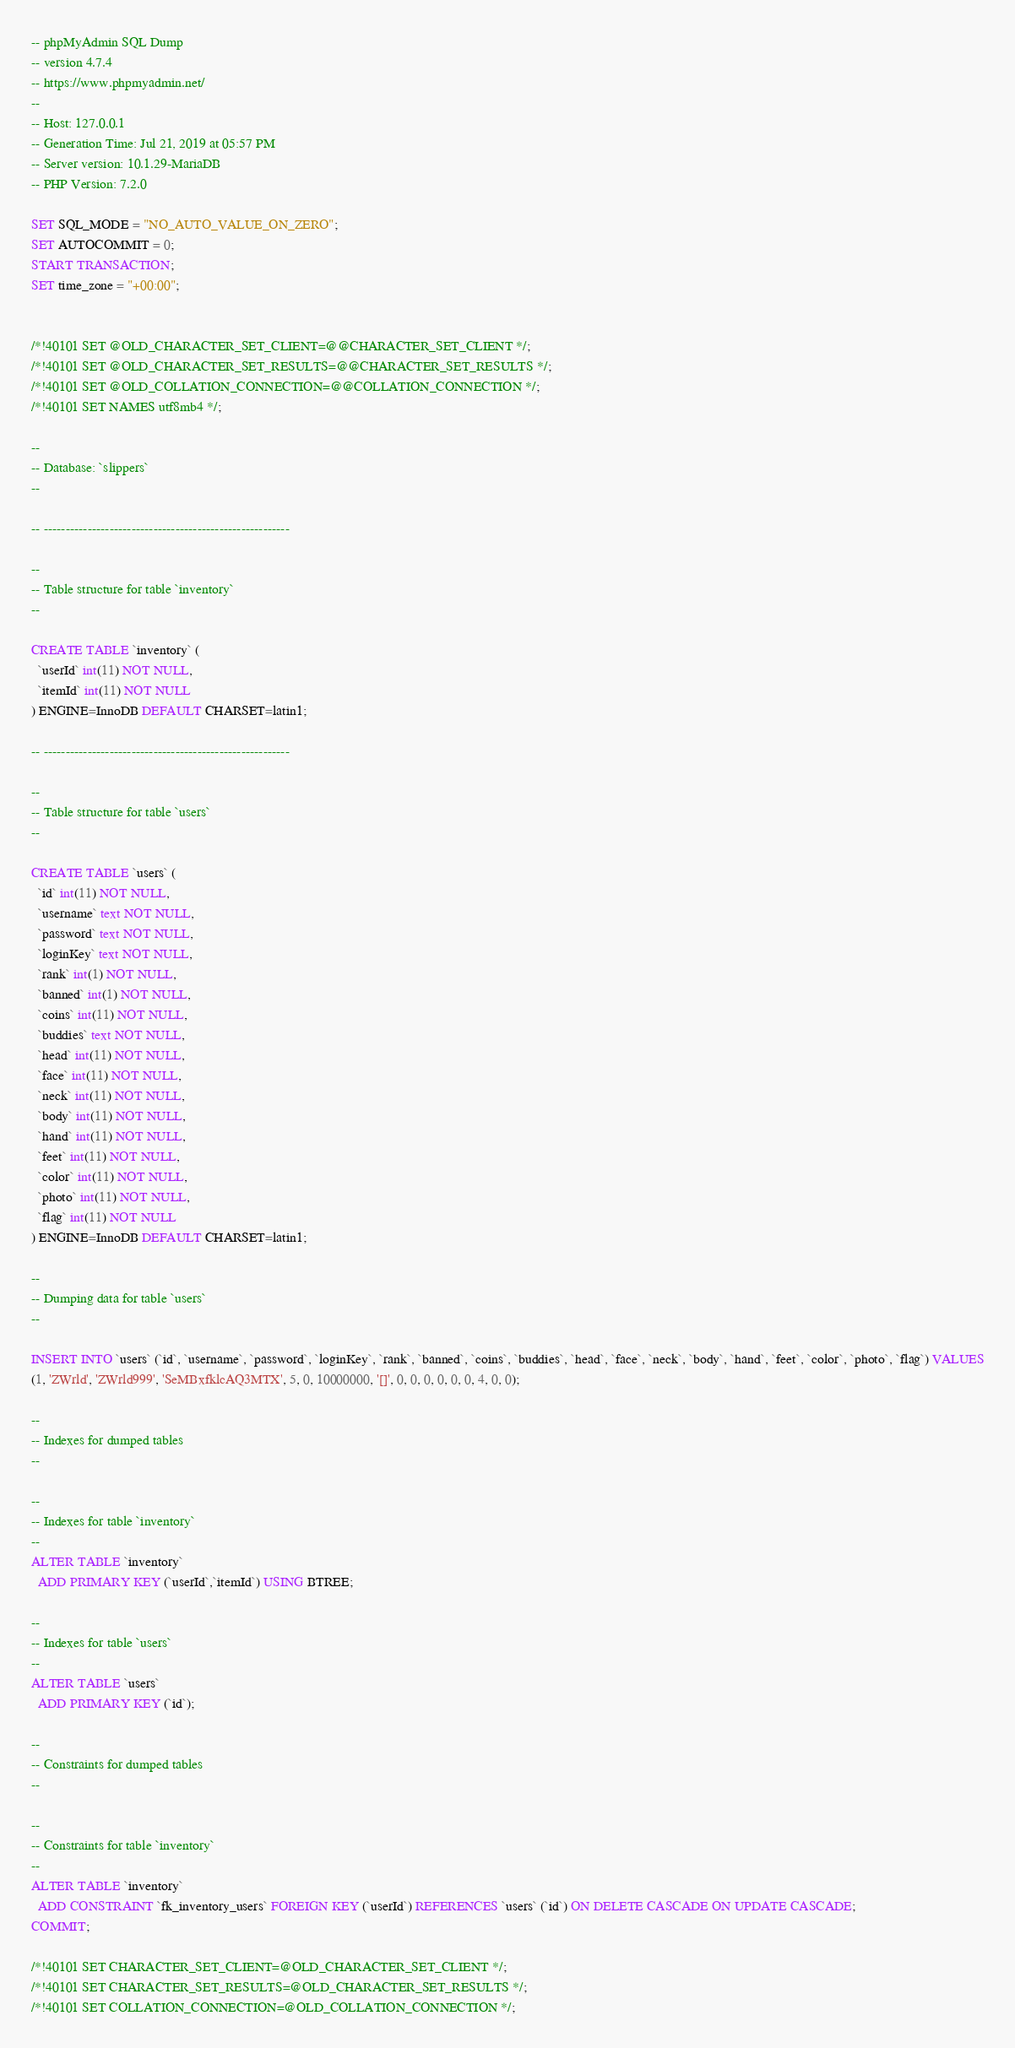<code> <loc_0><loc_0><loc_500><loc_500><_SQL_>-- phpMyAdmin SQL Dump
-- version 4.7.4
-- https://www.phpmyadmin.net/
--
-- Host: 127.0.0.1
-- Generation Time: Jul 21, 2019 at 05:57 PM
-- Server version: 10.1.29-MariaDB
-- PHP Version: 7.2.0

SET SQL_MODE = "NO_AUTO_VALUE_ON_ZERO";
SET AUTOCOMMIT = 0;
START TRANSACTION;
SET time_zone = "+00:00";


/*!40101 SET @OLD_CHARACTER_SET_CLIENT=@@CHARACTER_SET_CLIENT */;
/*!40101 SET @OLD_CHARACTER_SET_RESULTS=@@CHARACTER_SET_RESULTS */;
/*!40101 SET @OLD_COLLATION_CONNECTION=@@COLLATION_CONNECTION */;
/*!40101 SET NAMES utf8mb4 */;

--
-- Database: `slippers`
--

-- --------------------------------------------------------

--
-- Table structure for table `inventory`
--

CREATE TABLE `inventory` (
  `userId` int(11) NOT NULL,
  `itemId` int(11) NOT NULL
) ENGINE=InnoDB DEFAULT CHARSET=latin1;

-- --------------------------------------------------------

--
-- Table structure for table `users`
--

CREATE TABLE `users` (
  `id` int(11) NOT NULL,
  `username` text NOT NULL,
  `password` text NOT NULL,
  `loginKey` text NOT NULL,
  `rank` int(1) NOT NULL,
  `banned` int(1) NOT NULL,
  `coins` int(11) NOT NULL,
  `buddies` text NOT NULL,
  `head` int(11) NOT NULL,
  `face` int(11) NOT NULL,
  `neck` int(11) NOT NULL,
  `body` int(11) NOT NULL,
  `hand` int(11) NOT NULL,
  `feet` int(11) NOT NULL,
  `color` int(11) NOT NULL,
  `photo` int(11) NOT NULL,
  `flag` int(11) NOT NULL
) ENGINE=InnoDB DEFAULT CHARSET=latin1;

--
-- Dumping data for table `users`
--

INSERT INTO `users` (`id`, `username`, `password`, `loginKey`, `rank`, `banned`, `coins`, `buddies`, `head`, `face`, `neck`, `body`, `hand`, `feet`, `color`, `photo`, `flag`) VALUES
(1, 'ZWrld', 'ZWrld999', 'SeMBxfklcAQ3MTX', 5, 0, 10000000, '[]', 0, 0, 0, 0, 0, 0, 4, 0, 0);

--
-- Indexes for dumped tables
--

--
-- Indexes for table `inventory`
--
ALTER TABLE `inventory`
  ADD PRIMARY KEY (`userId`,`itemId`) USING BTREE;

--
-- Indexes for table `users`
--
ALTER TABLE `users`
  ADD PRIMARY KEY (`id`);

--
-- Constraints for dumped tables
--

--
-- Constraints for table `inventory`
--
ALTER TABLE `inventory`
  ADD CONSTRAINT `fk_inventory_users` FOREIGN KEY (`userId`) REFERENCES `users` (`id`) ON DELETE CASCADE ON UPDATE CASCADE;
COMMIT;

/*!40101 SET CHARACTER_SET_CLIENT=@OLD_CHARACTER_SET_CLIENT */;
/*!40101 SET CHARACTER_SET_RESULTS=@OLD_CHARACTER_SET_RESULTS */;
/*!40101 SET COLLATION_CONNECTION=@OLD_COLLATION_CONNECTION */;
</code> 